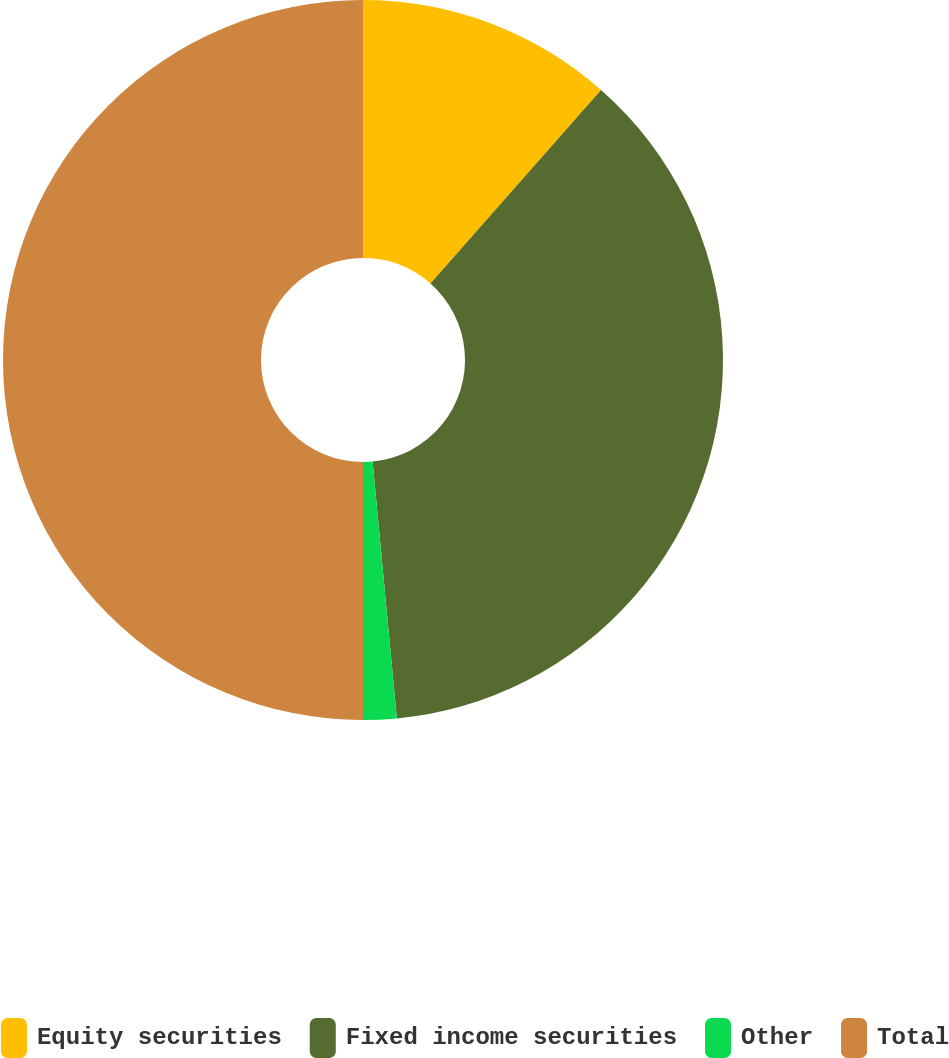Convert chart to OTSL. <chart><loc_0><loc_0><loc_500><loc_500><pie_chart><fcel>Equity securities<fcel>Fixed income securities<fcel>Other<fcel>Total<nl><fcel>11.5%<fcel>37.0%<fcel>1.5%<fcel>50.0%<nl></chart> 